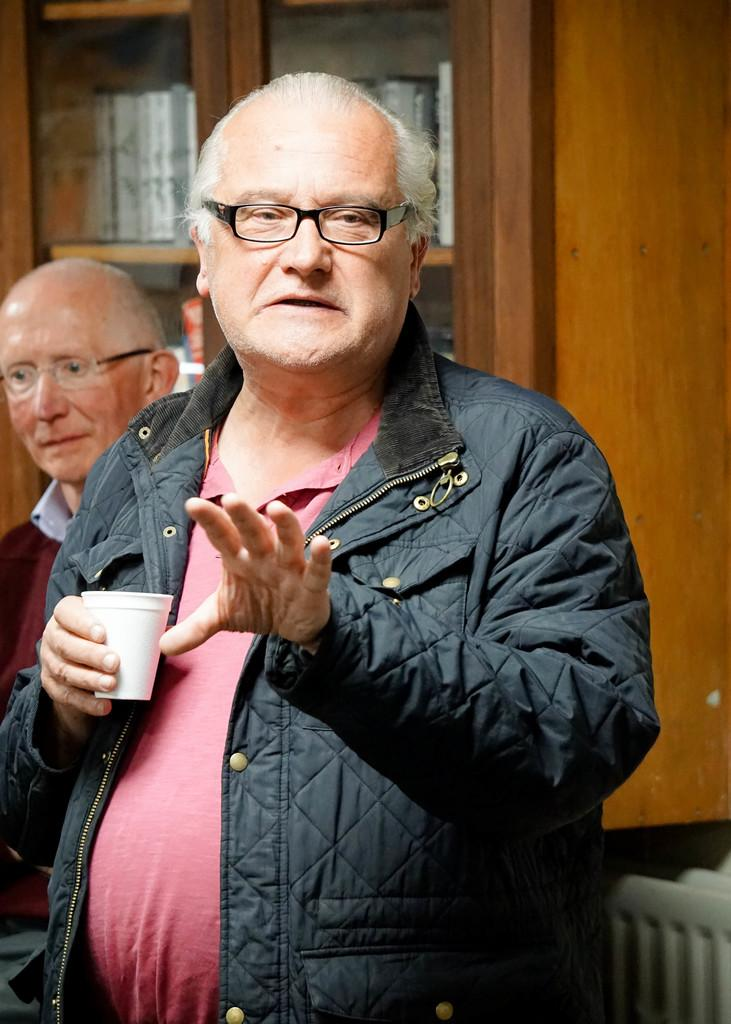What is the appearance of the man in the foreground of the image? There is an old man in a black jacket in the image. What is the old man holding in the image? The old man is holding a cup. Can you describe the position of the second old man in the image? There is another old man behind the first one. What can be seen in the background of the image? There is a cupboard in the background of the image. What is stored inside the cupboard? The cupboard contains books. What type of pan is visible on the wall in the image? There is no pan visible on the wall in the image. What kind of truck can be seen driving past the old men in the image? There is no truck present in the image; it features two old men and a cupboard with books. 